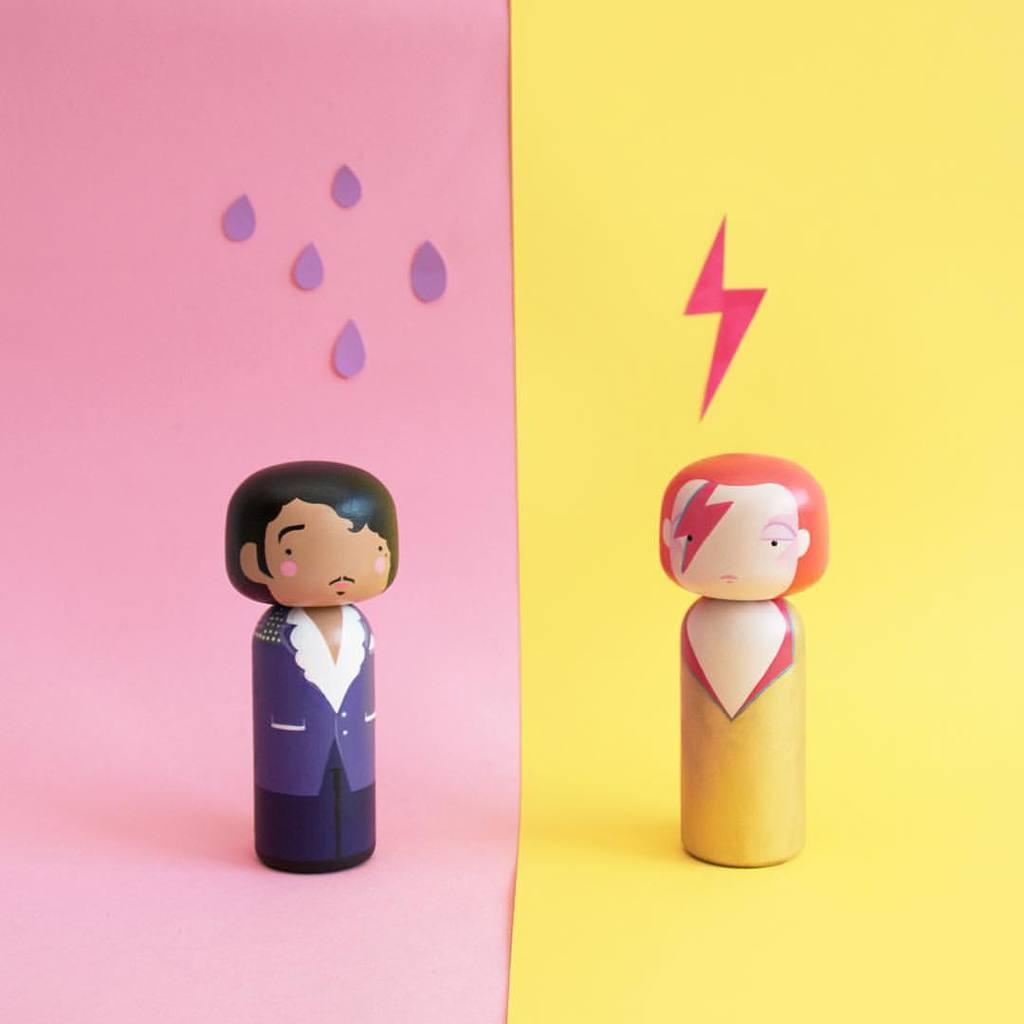Could you give a brief overview of what you see in this image? In this image we can see two dolls placed on the surface. 